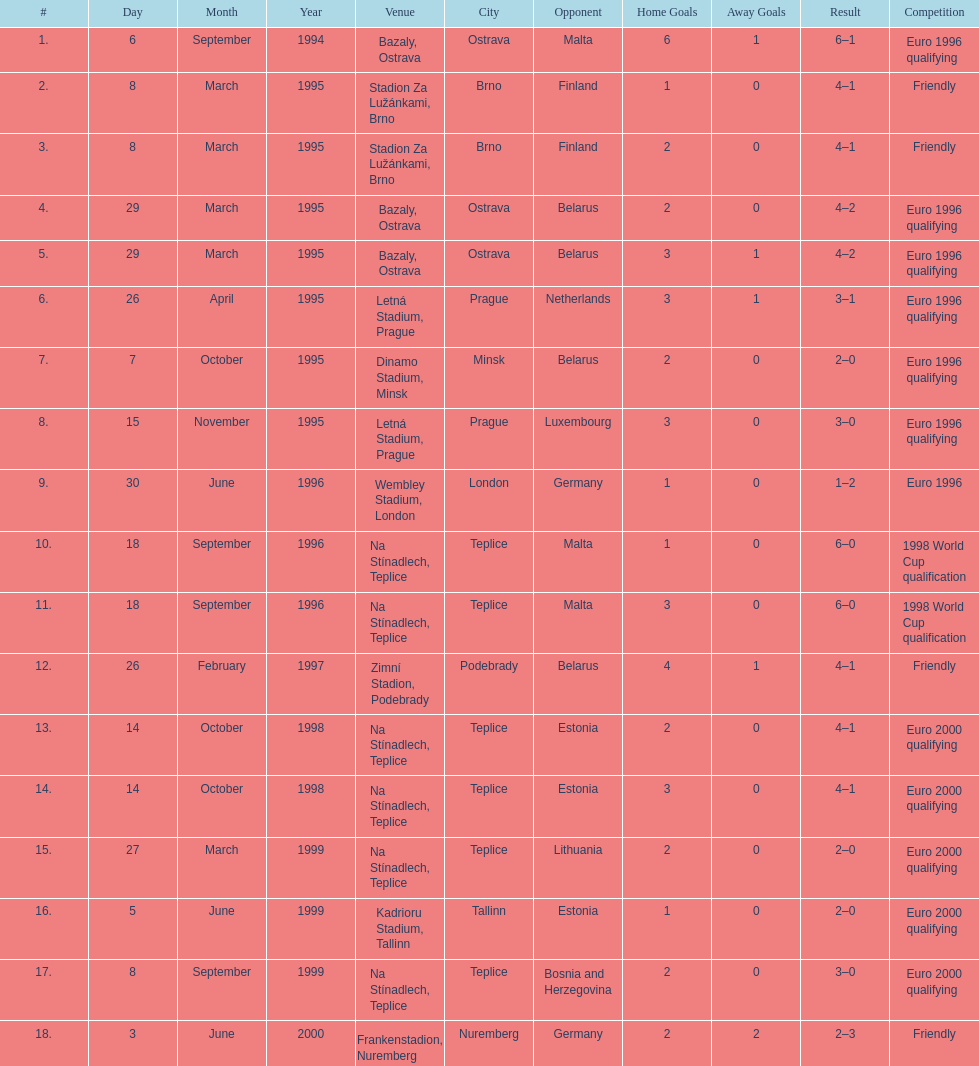Can you give me this table as a dict? {'header': ['#', 'Day', 'Month', 'Year', 'Venue', 'City', 'Opponent', 'Home Goals', 'Away Goals', 'Result', 'Competition'], 'rows': [['1.', '6', 'September', '1994', 'Bazaly, Ostrava', 'Ostrava', 'Malta', '6', '1', '6–1', 'Euro 1996 qualifying'], ['2.', '8', 'March', '1995', 'Stadion Za Lužánkami, Brno', 'Brno', 'Finland', '1', '0', '4–1', 'Friendly'], ['3.', '8', 'March', '1995', 'Stadion Za Lužánkami, Brno', 'Brno', 'Finland', '2', '0', '4–1', 'Friendly'], ['4.', '29', 'March', '1995', 'Bazaly, Ostrava', 'Ostrava', 'Belarus', '2', '0', '4–2', 'Euro 1996 qualifying'], ['5.', '29', 'March', '1995', 'Bazaly, Ostrava', 'Ostrava', 'Belarus', '3', '1', '4–2', 'Euro 1996 qualifying'], ['6.', '26', 'April', '1995', 'Letná Stadium, Prague', 'Prague', 'Netherlands', '3', '1', '3–1', 'Euro 1996 qualifying'], ['7.', '7', 'October', '1995', 'Dinamo Stadium, Minsk', 'Minsk', 'Belarus', '2', '0', '2–0', 'Euro 1996 qualifying'], ['8.', '15', 'November', '1995', 'Letná Stadium, Prague', 'Prague', 'Luxembourg', '3', '0', '3–0', 'Euro 1996 qualifying'], ['9.', '30', 'June', '1996', 'Wembley Stadium, London', 'London', 'Germany', '1', '0', '1–2', 'Euro 1996'], ['10.', '18', 'September', '1996', 'Na Stínadlech, Teplice', 'Teplice', 'Malta', '1', '0', '6–0', '1998 World Cup qualification'], ['11.', '18', 'September', '1996', 'Na Stínadlech, Teplice', 'Teplice', 'Malta', '3', '0', '6–0', '1998 World Cup qualification'], ['12.', '26', 'February', '1997', 'Zimní Stadion, Podebrady', 'Podebrady', 'Belarus', '4', '1', '4–1', 'Friendly'], ['13.', '14', 'October', '1998', 'Na Stínadlech, Teplice', 'Teplice', 'Estonia', '2', '0', '4–1', 'Euro 2000 qualifying'], ['14.', '14', 'October', '1998', 'Na Stínadlech, Teplice', 'Teplice', 'Estonia', '3', '0', '4–1', 'Euro 2000 qualifying'], ['15.', '27', 'March', '1999', 'Na Stínadlech, Teplice', 'Teplice', 'Lithuania', '2', '0', '2–0', 'Euro 2000 qualifying'], ['16.', '5', 'June', '1999', 'Kadrioru Stadium, Tallinn', 'Tallinn', 'Estonia', '1', '0', '2–0', 'Euro 2000 qualifying'], ['17.', '8', 'September', '1999', 'Na Stínadlech, Teplice', 'Teplice', 'Bosnia and Herzegovina', '2', '0', '3–0', 'Euro 2000 qualifying'], ['18.', '3', 'June', '2000', 'Frankenstadion, Nuremberg', 'Nuremberg', 'Germany', '2', '2', '2–3', 'Friendly']]} How many euro 2000 qualifying competitions are listed? 4. 